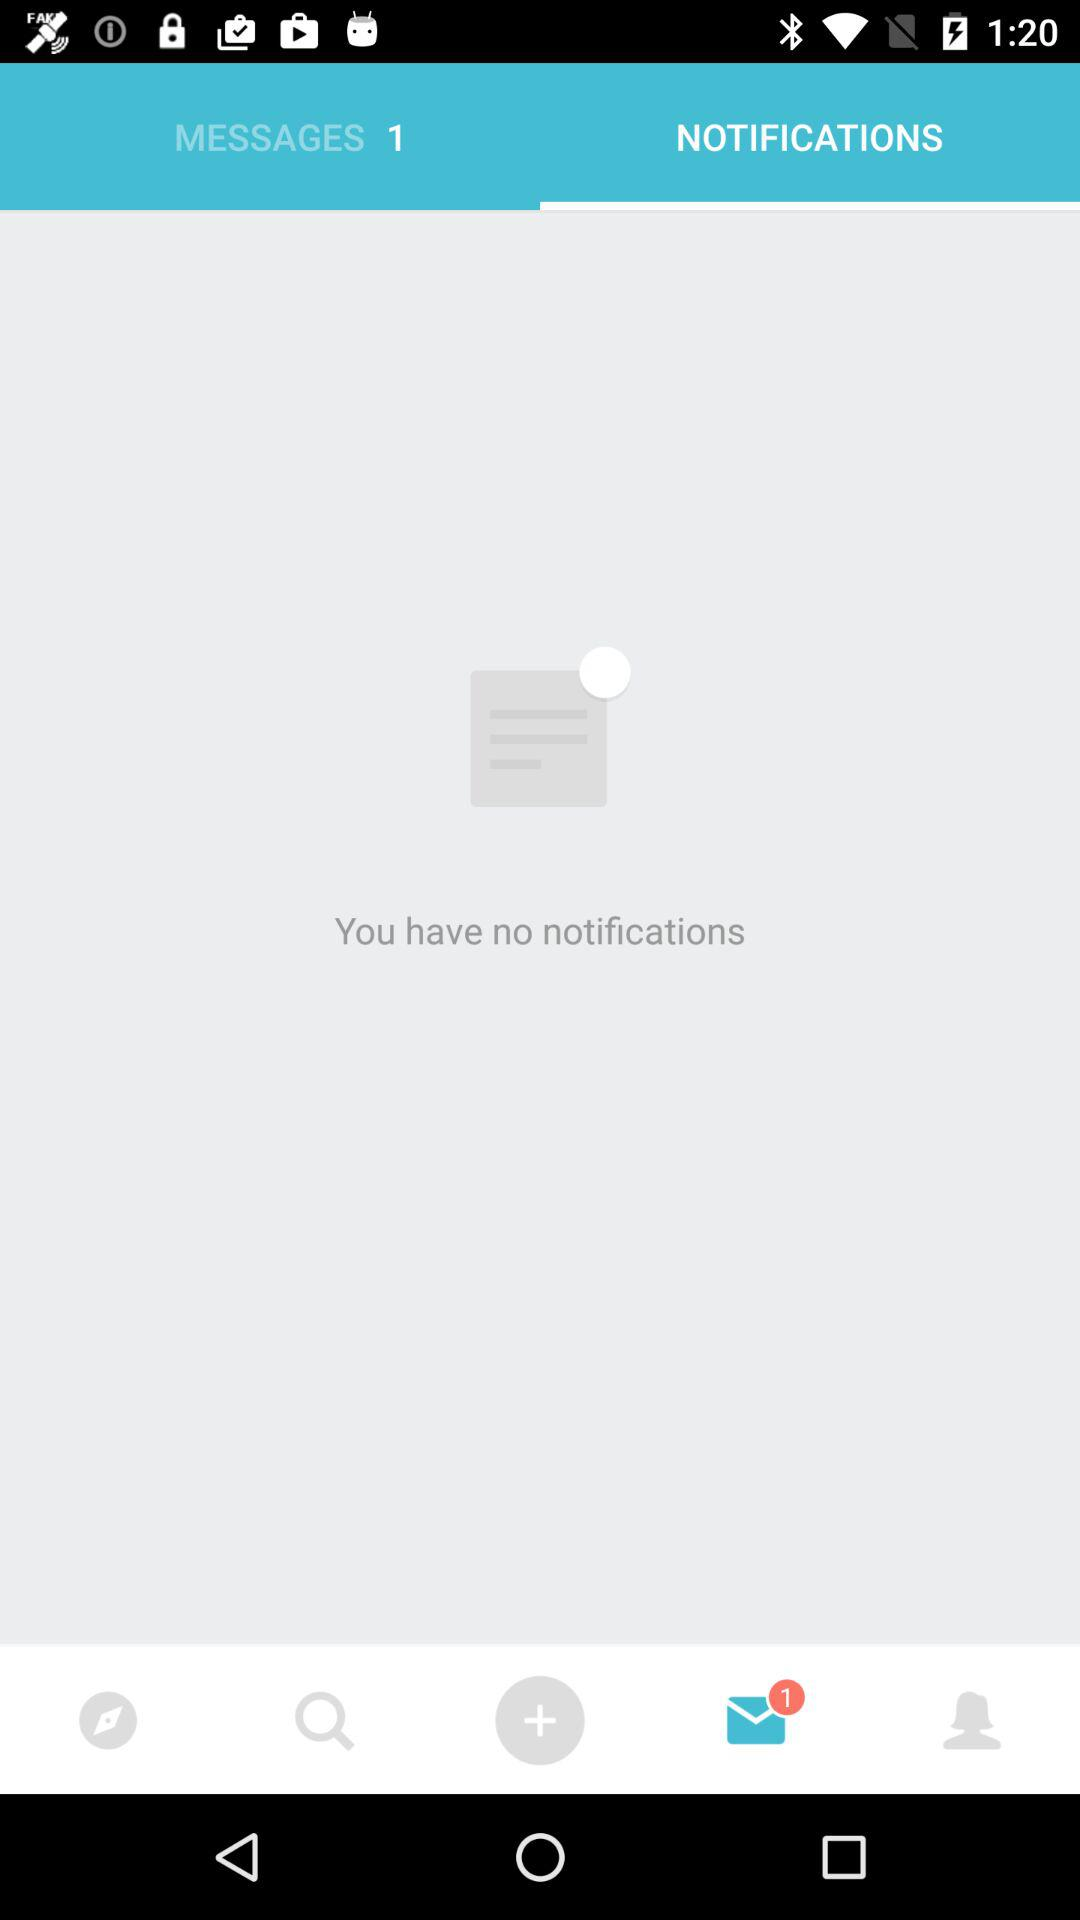How many unread messages are there? There is 1 unread message. 